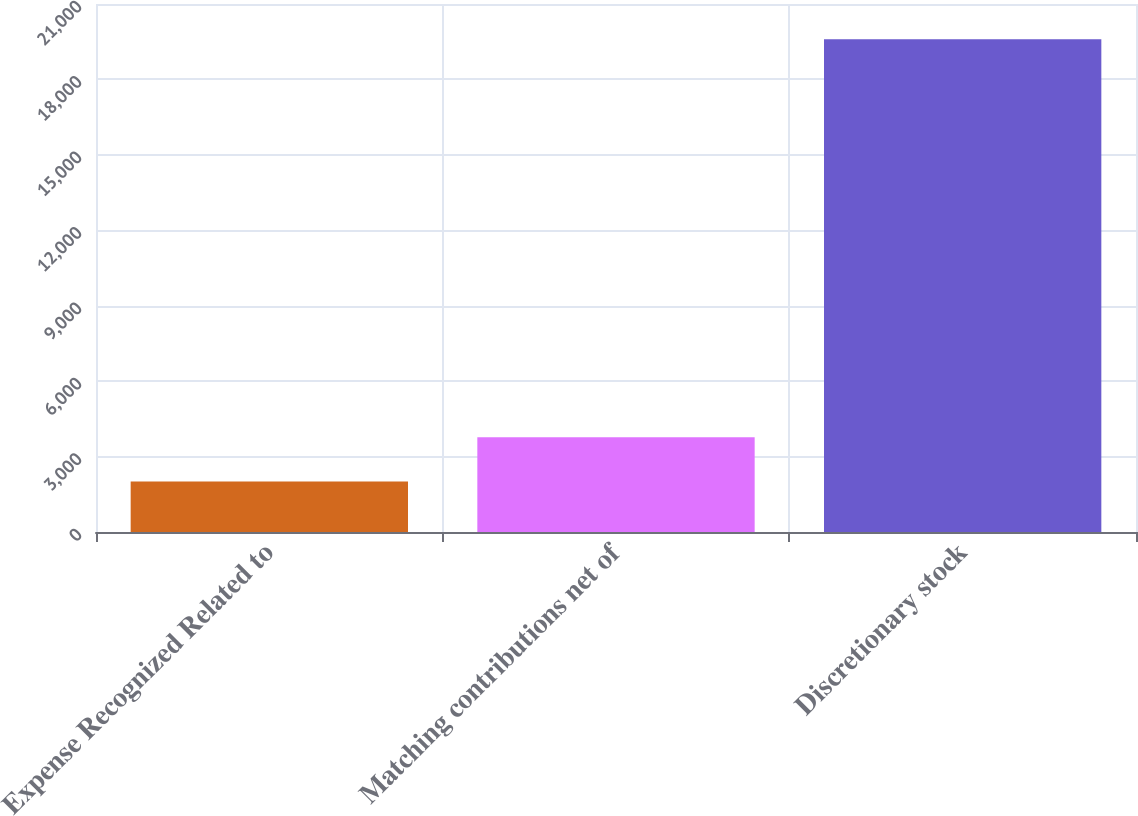<chart> <loc_0><loc_0><loc_500><loc_500><bar_chart><fcel>Expense Recognized Related to<fcel>Matching contributions net of<fcel>Discretionary stock<nl><fcel>2007<fcel>3765.7<fcel>19594<nl></chart> 